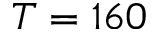Convert formula to latex. <formula><loc_0><loc_0><loc_500><loc_500>T = 1 6 0</formula> 